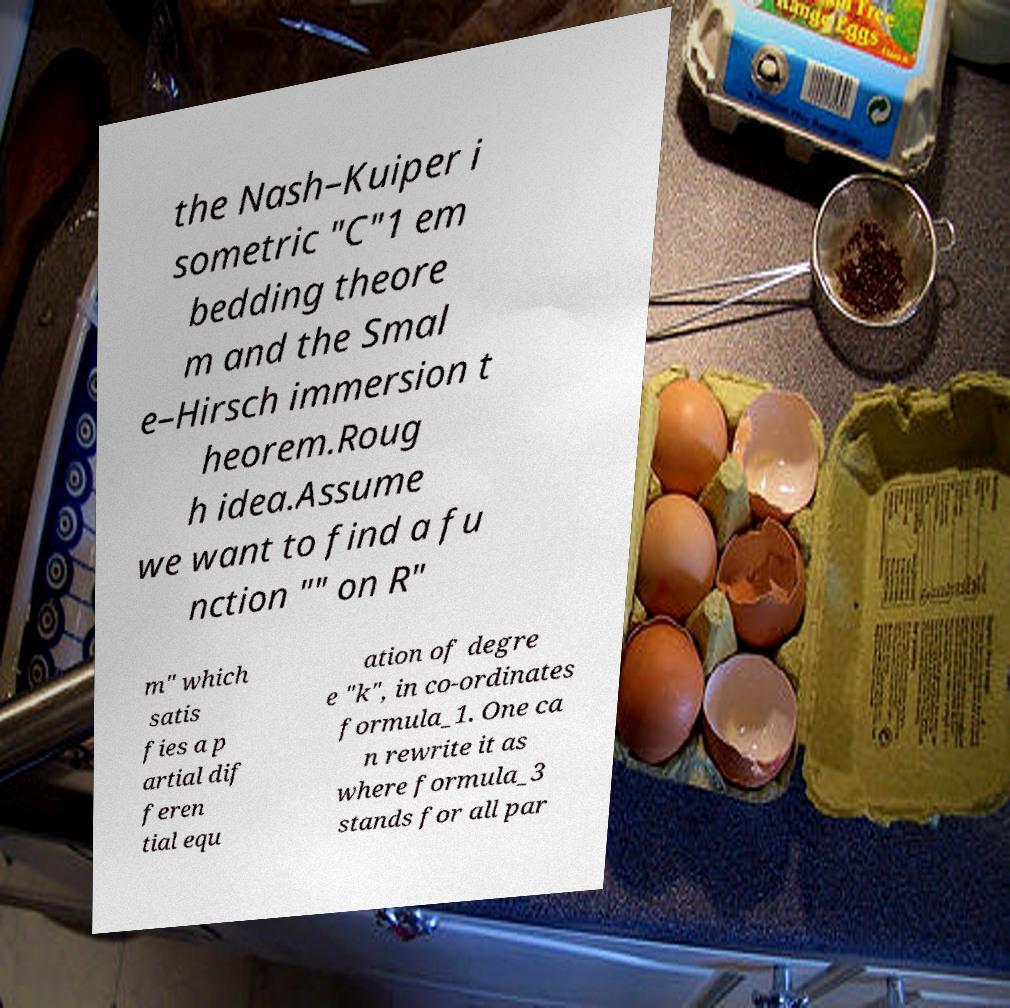Can you accurately transcribe the text from the provided image for me? the Nash–Kuiper i sometric "C"1 em bedding theore m and the Smal e–Hirsch immersion t heorem.Roug h idea.Assume we want to find a fu nction "" on R" m" which satis fies a p artial dif feren tial equ ation of degre e "k", in co-ordinates formula_1. One ca n rewrite it as where formula_3 stands for all par 